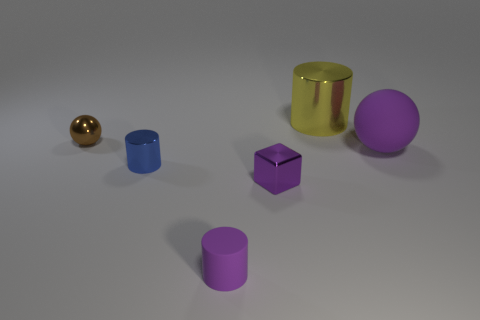Are there any purple objects made of the same material as the small block?
Give a very brief answer. No. How many things are either tiny metallic cylinders left of the large ball or small objects that are in front of the brown ball?
Ensure brevity in your answer.  3. Do the blue object and the purple rubber object that is to the left of the yellow cylinder have the same shape?
Keep it short and to the point. Yes. What number of other objects are there of the same shape as the large yellow object?
Give a very brief answer. 2. How many things are either small brown shiny balls or big brown rubber balls?
Make the answer very short. 1. Do the tiny block and the shiny ball have the same color?
Keep it short and to the point. No. Is there any other thing that is the same size as the yellow cylinder?
Keep it short and to the point. Yes. What is the shape of the small metal thing behind the shiny cylinder that is in front of the brown sphere?
Give a very brief answer. Sphere. Are there fewer big yellow things than big purple cubes?
Give a very brief answer. No. There is a cylinder that is both on the left side of the big metallic cylinder and behind the purple shiny object; how big is it?
Keep it short and to the point. Small. 